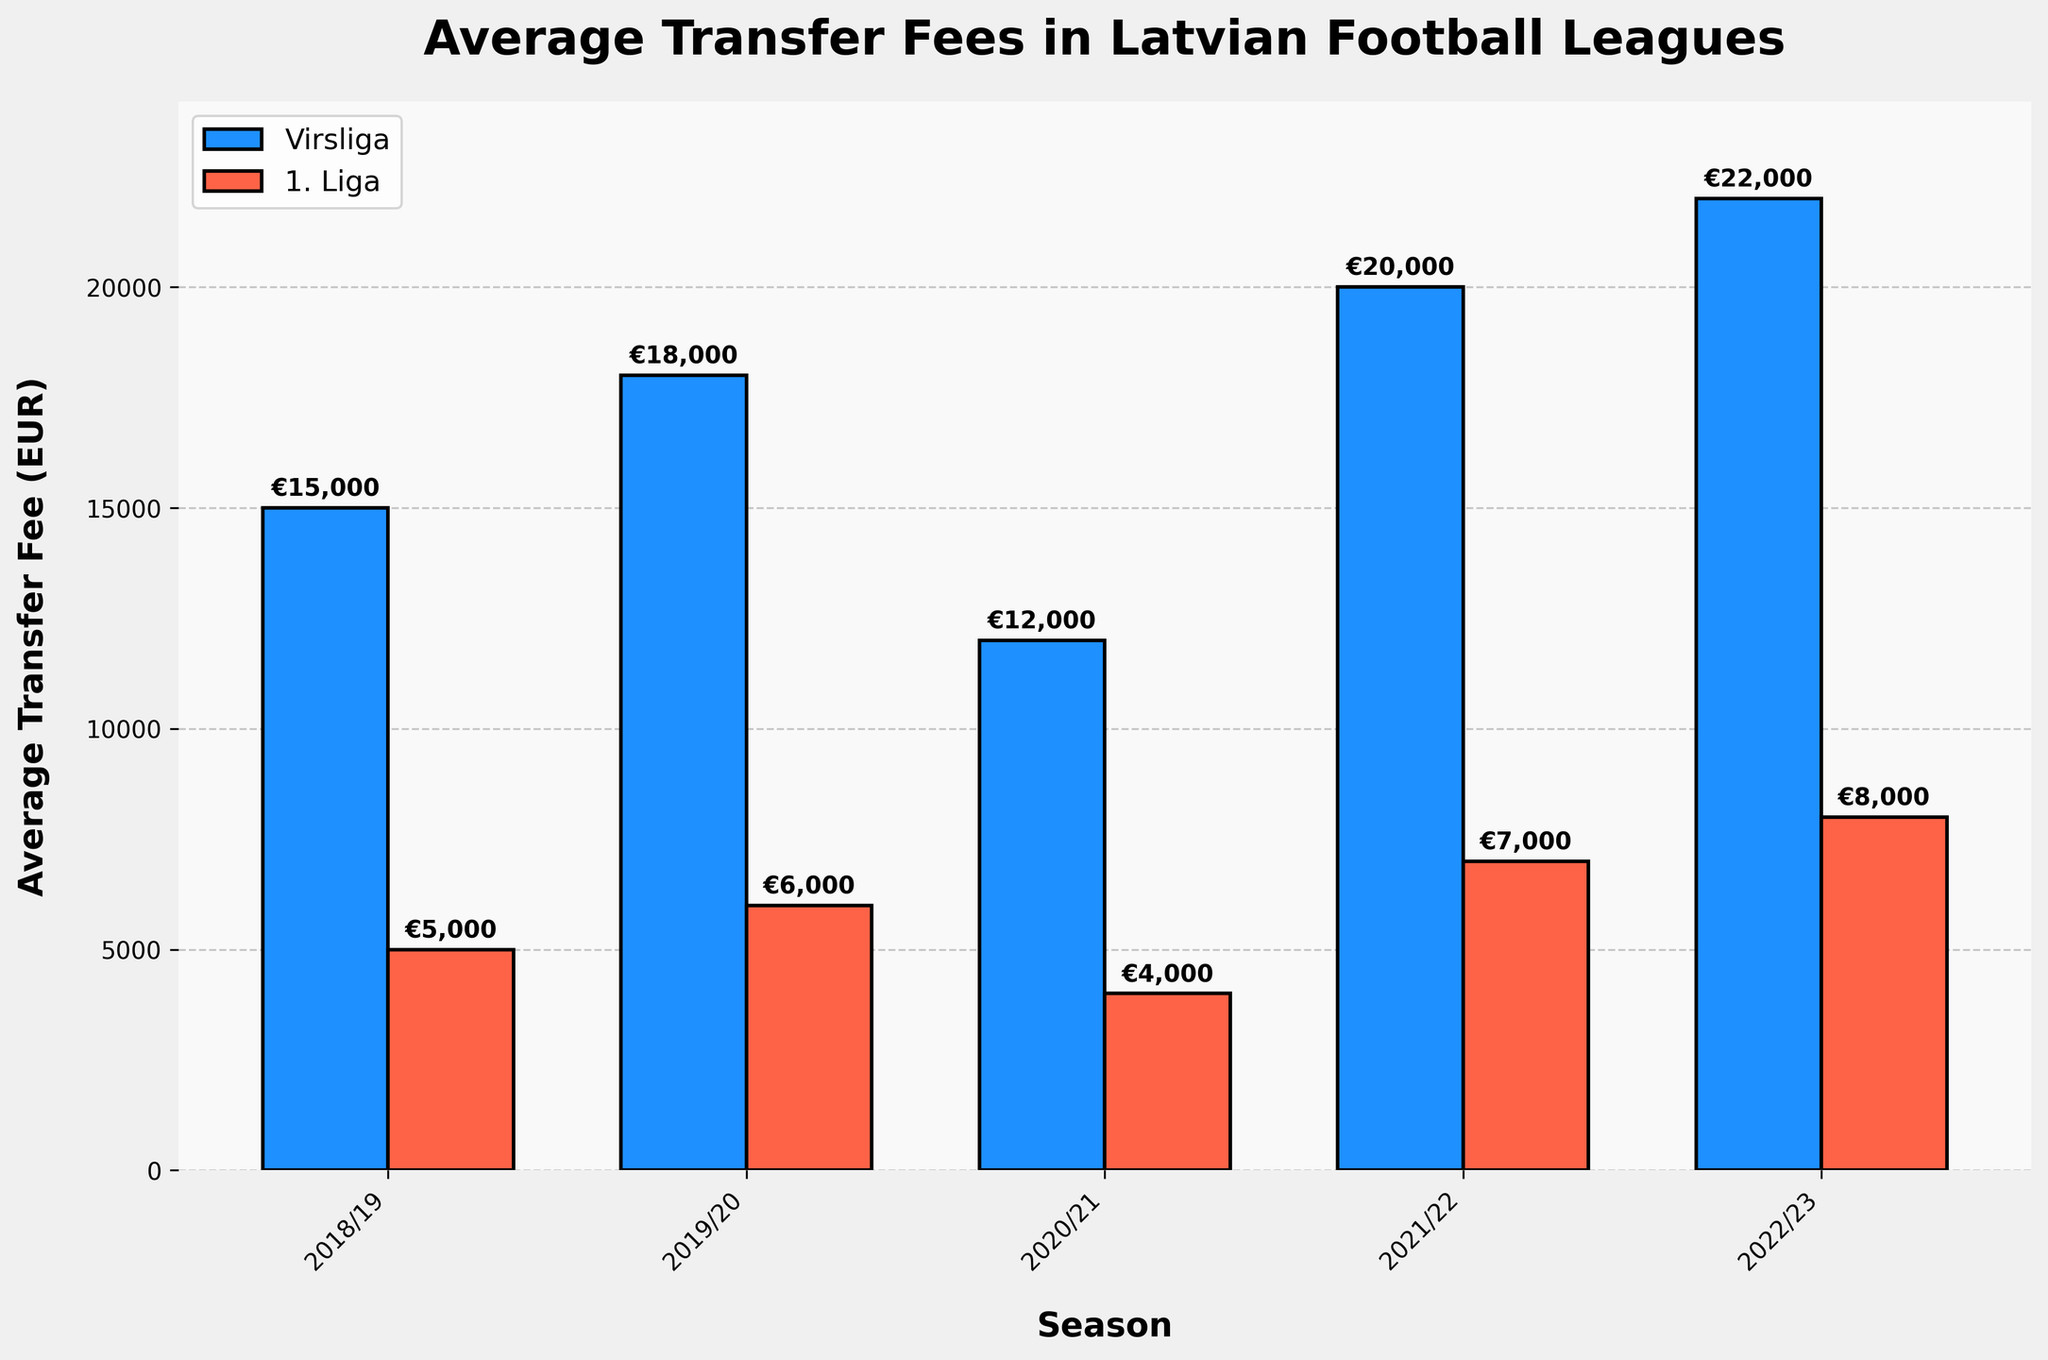What is the average transfer fee for Virsliga in the 2022/23 season? Observe the bar labeled "2022/23" under the Virsliga category (blue bar). The height indicates the value, which is €22,000.
Answer: €22,000 Which league had a higher average transfer fee in the 2019/20 season? Compare the heights of the bars for the 2019/20 season. The blue bar (Virsliga) is higher than the red bar (1. Liga).
Answer: Virsliga What is the total average transfer fee for 1. Liga over all the seasons? Sum the heights of all red bars, which represent 1. Liga, for each season: €5000 + €6000 + €4000 + €7000 + €8000. The total is €30,000.
Answer: €30,000 How much more was the transfer fee for Virsliga compared to 1. Liga in the 2021/22 season? Subtract the height of the red bar for the 2021/22 season (1. Liga - €7,000) from the height of the blue bar (Virsliga - €20,000). The difference is €20,000 - €7,000 = €13,000.
Answer: €13,000 Which season shows the largest difference in average transfer fees between Virsliga and 1. Liga? Calculate the difference for each season and identify the largest one. 
2018/19: €15,000 - €5,000 = €10,000
2019/20: €18,000 - €6,000 = €12,000
2020/21: €12,000 - €4,000 = €8,000
2021/22: €20,000 - €7,000 = €13,000
2022/23: €22,000 - €8,000 = €14,000
The largest difference is €14,000 in the 2022/23 season.
Answer: 2022/23 What is the average transfer fee for Virsliga across all seasons? Sum the heights of all blue bars (Virsliga) and divide by the number of seasons: (€15,000 + €18,000 + €12,000 + €20,000 + €22,000) / 5. The sum is €87,000 and the average is €87,000 / 5 = €17,400.
Answer: €17,400 In which season did the average transfer fee for 1. Liga reach its peak? Identify the tallest red bar (1. Liga) across all seasons, which is for the 2022/23 season with €8,000.
Answer: 2022/23 By how much did the average transfer fee for Virsliga increase from 2020/21 to 2021/22? Subtract the fee for 2020/21 (€12,000) from 2021/22 (€20,000). The increase is €20,000 - €12,000 = €8,000.
Answer: €8,000 